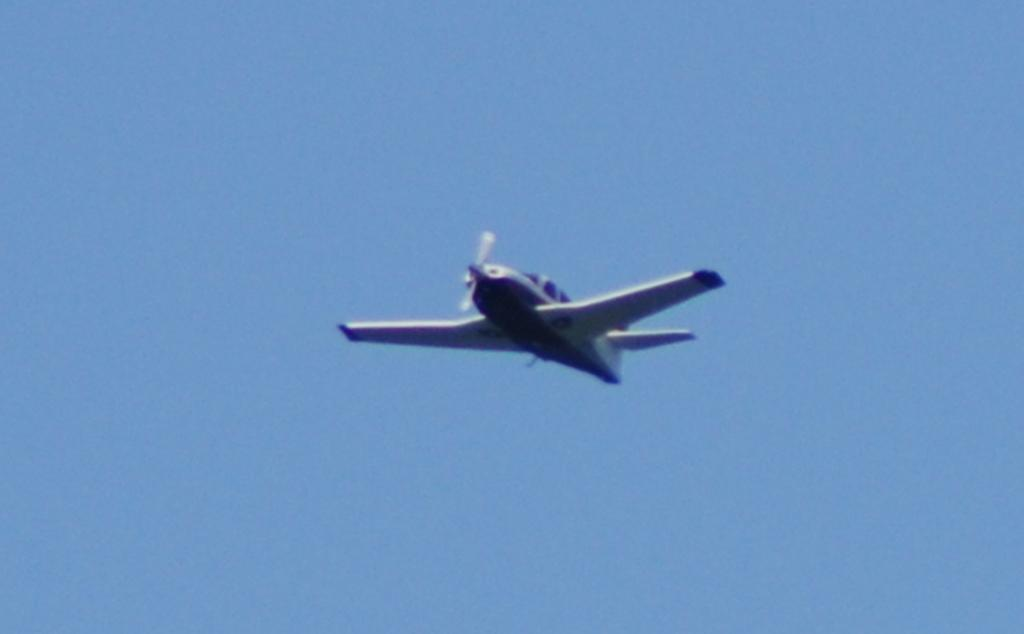What is the main subject of the image? The main subject of the image is an airplane. What is the airplane doing in the image? The airplane is flying in the sky. Where is the fork placed in the image? There is no fork present in the image. What type of fuel is being used by the airplane in the image? The image does not provide information about the type of fuel being used by the airplane. 